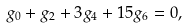<formula> <loc_0><loc_0><loc_500><loc_500>g _ { 0 } + g _ { 2 } + 3 g _ { 4 } + 1 5 g _ { 6 } = 0 ,</formula> 